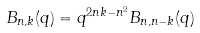<formula> <loc_0><loc_0><loc_500><loc_500>B _ { n , k } ( q ) = q ^ { 2 n k - n ^ { 2 } } B _ { n , n - k } ( q )</formula> 